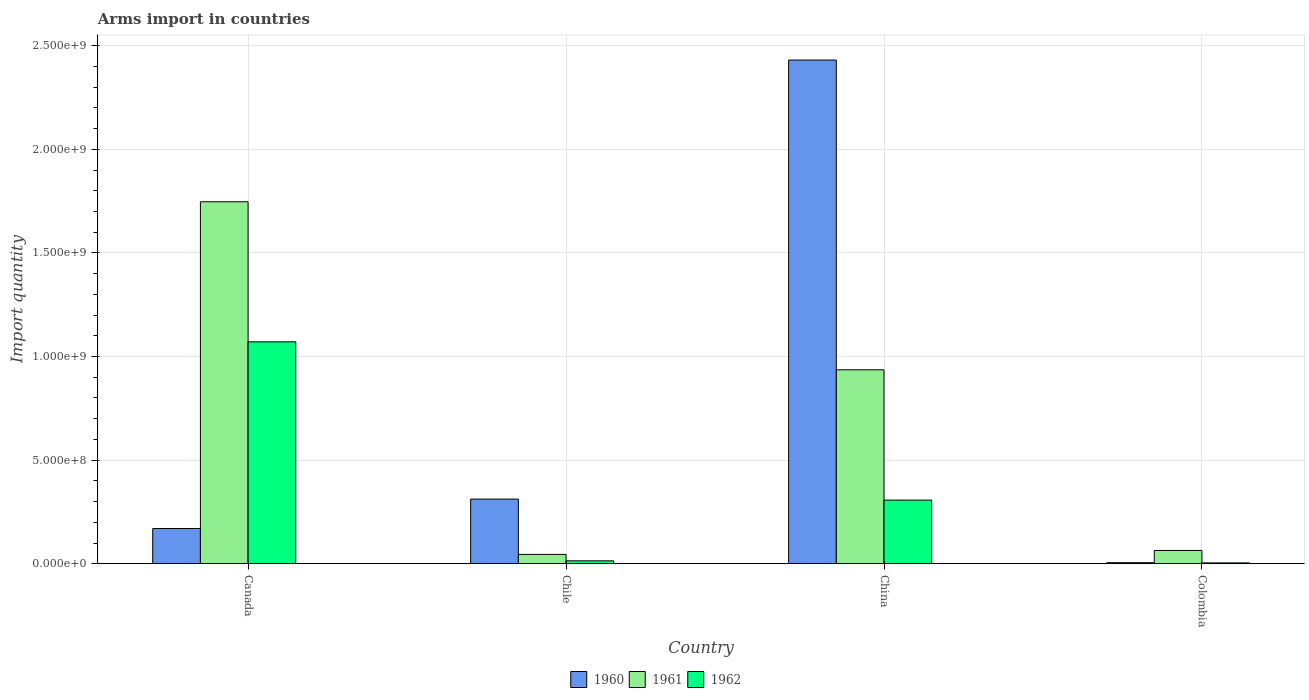Are the number of bars on each tick of the X-axis equal?
Your answer should be compact. Yes. How many bars are there on the 4th tick from the left?
Your response must be concise. 3. How many bars are there on the 4th tick from the right?
Provide a succinct answer. 3. What is the label of the 4th group of bars from the left?
Offer a terse response. Colombia. In how many cases, is the number of bars for a given country not equal to the number of legend labels?
Make the answer very short. 0. What is the total arms import in 1960 in China?
Offer a terse response. 2.43e+09. Across all countries, what is the maximum total arms import in 1961?
Provide a succinct answer. 1.75e+09. Across all countries, what is the minimum total arms import in 1962?
Your answer should be very brief. 4.00e+06. What is the total total arms import in 1961 in the graph?
Offer a very short reply. 2.79e+09. What is the difference between the total arms import in 1962 in China and that in Colombia?
Provide a succinct answer. 3.03e+08. What is the difference between the total arms import in 1961 in Colombia and the total arms import in 1960 in Canada?
Provide a short and direct response. -1.06e+08. What is the average total arms import in 1961 per country?
Provide a short and direct response. 6.98e+08. What is the difference between the total arms import of/in 1962 and total arms import of/in 1960 in Canada?
Give a very brief answer. 9.01e+08. In how many countries, is the total arms import in 1961 greater than 2300000000?
Give a very brief answer. 0. What is the ratio of the total arms import in 1961 in Canada to that in Chile?
Give a very brief answer. 38.82. Is the total arms import in 1960 in China less than that in Colombia?
Your answer should be very brief. No. What is the difference between the highest and the second highest total arms import in 1962?
Give a very brief answer. 1.06e+09. What is the difference between the highest and the lowest total arms import in 1960?
Provide a succinct answer. 2.43e+09. What does the 1st bar from the left in Chile represents?
Your response must be concise. 1960. Is it the case that in every country, the sum of the total arms import in 1962 and total arms import in 1961 is greater than the total arms import in 1960?
Provide a succinct answer. No. Are all the bars in the graph horizontal?
Give a very brief answer. No. How many countries are there in the graph?
Provide a succinct answer. 4. Are the values on the major ticks of Y-axis written in scientific E-notation?
Your response must be concise. Yes. Does the graph contain grids?
Your answer should be compact. Yes. What is the title of the graph?
Ensure brevity in your answer.  Arms import in countries. What is the label or title of the X-axis?
Provide a short and direct response. Country. What is the label or title of the Y-axis?
Provide a succinct answer. Import quantity. What is the Import quantity of 1960 in Canada?
Offer a terse response. 1.70e+08. What is the Import quantity of 1961 in Canada?
Keep it short and to the point. 1.75e+09. What is the Import quantity in 1962 in Canada?
Make the answer very short. 1.07e+09. What is the Import quantity in 1960 in Chile?
Offer a very short reply. 3.12e+08. What is the Import quantity of 1961 in Chile?
Your answer should be compact. 4.50e+07. What is the Import quantity in 1962 in Chile?
Provide a succinct answer. 1.40e+07. What is the Import quantity in 1960 in China?
Ensure brevity in your answer.  2.43e+09. What is the Import quantity in 1961 in China?
Give a very brief answer. 9.36e+08. What is the Import quantity of 1962 in China?
Provide a succinct answer. 3.07e+08. What is the Import quantity of 1961 in Colombia?
Offer a terse response. 6.40e+07. What is the Import quantity of 1962 in Colombia?
Provide a short and direct response. 4.00e+06. Across all countries, what is the maximum Import quantity in 1960?
Your answer should be compact. 2.43e+09. Across all countries, what is the maximum Import quantity in 1961?
Ensure brevity in your answer.  1.75e+09. Across all countries, what is the maximum Import quantity of 1962?
Keep it short and to the point. 1.07e+09. Across all countries, what is the minimum Import quantity of 1960?
Offer a very short reply. 5.00e+06. Across all countries, what is the minimum Import quantity of 1961?
Your answer should be compact. 4.50e+07. Across all countries, what is the minimum Import quantity in 1962?
Make the answer very short. 4.00e+06. What is the total Import quantity of 1960 in the graph?
Make the answer very short. 2.92e+09. What is the total Import quantity of 1961 in the graph?
Provide a short and direct response. 2.79e+09. What is the total Import quantity in 1962 in the graph?
Offer a terse response. 1.40e+09. What is the difference between the Import quantity in 1960 in Canada and that in Chile?
Provide a succinct answer. -1.42e+08. What is the difference between the Import quantity in 1961 in Canada and that in Chile?
Provide a short and direct response. 1.70e+09. What is the difference between the Import quantity in 1962 in Canada and that in Chile?
Ensure brevity in your answer.  1.06e+09. What is the difference between the Import quantity of 1960 in Canada and that in China?
Make the answer very short. -2.26e+09. What is the difference between the Import quantity in 1961 in Canada and that in China?
Ensure brevity in your answer.  8.11e+08. What is the difference between the Import quantity of 1962 in Canada and that in China?
Keep it short and to the point. 7.64e+08. What is the difference between the Import quantity of 1960 in Canada and that in Colombia?
Offer a very short reply. 1.65e+08. What is the difference between the Import quantity of 1961 in Canada and that in Colombia?
Provide a short and direct response. 1.68e+09. What is the difference between the Import quantity of 1962 in Canada and that in Colombia?
Provide a succinct answer. 1.07e+09. What is the difference between the Import quantity of 1960 in Chile and that in China?
Offer a terse response. -2.12e+09. What is the difference between the Import quantity of 1961 in Chile and that in China?
Provide a succinct answer. -8.91e+08. What is the difference between the Import quantity in 1962 in Chile and that in China?
Make the answer very short. -2.93e+08. What is the difference between the Import quantity in 1960 in Chile and that in Colombia?
Your response must be concise. 3.07e+08. What is the difference between the Import quantity in 1961 in Chile and that in Colombia?
Your answer should be compact. -1.90e+07. What is the difference between the Import quantity in 1962 in Chile and that in Colombia?
Make the answer very short. 1.00e+07. What is the difference between the Import quantity of 1960 in China and that in Colombia?
Ensure brevity in your answer.  2.43e+09. What is the difference between the Import quantity in 1961 in China and that in Colombia?
Your response must be concise. 8.72e+08. What is the difference between the Import quantity of 1962 in China and that in Colombia?
Your answer should be very brief. 3.03e+08. What is the difference between the Import quantity in 1960 in Canada and the Import quantity in 1961 in Chile?
Your answer should be very brief. 1.25e+08. What is the difference between the Import quantity in 1960 in Canada and the Import quantity in 1962 in Chile?
Your answer should be very brief. 1.56e+08. What is the difference between the Import quantity in 1961 in Canada and the Import quantity in 1962 in Chile?
Provide a short and direct response. 1.73e+09. What is the difference between the Import quantity of 1960 in Canada and the Import quantity of 1961 in China?
Your answer should be very brief. -7.66e+08. What is the difference between the Import quantity in 1960 in Canada and the Import quantity in 1962 in China?
Your response must be concise. -1.37e+08. What is the difference between the Import quantity in 1961 in Canada and the Import quantity in 1962 in China?
Provide a short and direct response. 1.44e+09. What is the difference between the Import quantity in 1960 in Canada and the Import quantity in 1961 in Colombia?
Provide a succinct answer. 1.06e+08. What is the difference between the Import quantity of 1960 in Canada and the Import quantity of 1962 in Colombia?
Give a very brief answer. 1.66e+08. What is the difference between the Import quantity of 1961 in Canada and the Import quantity of 1962 in Colombia?
Keep it short and to the point. 1.74e+09. What is the difference between the Import quantity in 1960 in Chile and the Import quantity in 1961 in China?
Keep it short and to the point. -6.24e+08. What is the difference between the Import quantity in 1961 in Chile and the Import quantity in 1962 in China?
Ensure brevity in your answer.  -2.62e+08. What is the difference between the Import quantity of 1960 in Chile and the Import quantity of 1961 in Colombia?
Provide a short and direct response. 2.48e+08. What is the difference between the Import quantity in 1960 in Chile and the Import quantity in 1962 in Colombia?
Provide a short and direct response. 3.08e+08. What is the difference between the Import quantity of 1961 in Chile and the Import quantity of 1962 in Colombia?
Keep it short and to the point. 4.10e+07. What is the difference between the Import quantity in 1960 in China and the Import quantity in 1961 in Colombia?
Ensure brevity in your answer.  2.37e+09. What is the difference between the Import quantity of 1960 in China and the Import quantity of 1962 in Colombia?
Your answer should be very brief. 2.43e+09. What is the difference between the Import quantity in 1961 in China and the Import quantity in 1962 in Colombia?
Make the answer very short. 9.32e+08. What is the average Import quantity in 1960 per country?
Provide a short and direct response. 7.30e+08. What is the average Import quantity of 1961 per country?
Provide a short and direct response. 6.98e+08. What is the average Import quantity in 1962 per country?
Ensure brevity in your answer.  3.49e+08. What is the difference between the Import quantity in 1960 and Import quantity in 1961 in Canada?
Offer a very short reply. -1.58e+09. What is the difference between the Import quantity in 1960 and Import quantity in 1962 in Canada?
Provide a succinct answer. -9.01e+08. What is the difference between the Import quantity in 1961 and Import quantity in 1962 in Canada?
Offer a very short reply. 6.76e+08. What is the difference between the Import quantity in 1960 and Import quantity in 1961 in Chile?
Your response must be concise. 2.67e+08. What is the difference between the Import quantity in 1960 and Import quantity in 1962 in Chile?
Give a very brief answer. 2.98e+08. What is the difference between the Import quantity of 1961 and Import quantity of 1962 in Chile?
Give a very brief answer. 3.10e+07. What is the difference between the Import quantity of 1960 and Import quantity of 1961 in China?
Make the answer very short. 1.50e+09. What is the difference between the Import quantity of 1960 and Import quantity of 1962 in China?
Give a very brief answer. 2.12e+09. What is the difference between the Import quantity of 1961 and Import quantity of 1962 in China?
Provide a succinct answer. 6.29e+08. What is the difference between the Import quantity in 1960 and Import quantity in 1961 in Colombia?
Give a very brief answer. -5.90e+07. What is the difference between the Import quantity in 1960 and Import quantity in 1962 in Colombia?
Provide a succinct answer. 1.00e+06. What is the difference between the Import quantity of 1961 and Import quantity of 1962 in Colombia?
Provide a short and direct response. 6.00e+07. What is the ratio of the Import quantity of 1960 in Canada to that in Chile?
Provide a short and direct response. 0.54. What is the ratio of the Import quantity of 1961 in Canada to that in Chile?
Keep it short and to the point. 38.82. What is the ratio of the Import quantity of 1962 in Canada to that in Chile?
Ensure brevity in your answer.  76.5. What is the ratio of the Import quantity of 1960 in Canada to that in China?
Offer a terse response. 0.07. What is the ratio of the Import quantity in 1961 in Canada to that in China?
Provide a succinct answer. 1.87. What is the ratio of the Import quantity of 1962 in Canada to that in China?
Offer a very short reply. 3.49. What is the ratio of the Import quantity in 1961 in Canada to that in Colombia?
Offer a very short reply. 27.3. What is the ratio of the Import quantity in 1962 in Canada to that in Colombia?
Provide a succinct answer. 267.75. What is the ratio of the Import quantity of 1960 in Chile to that in China?
Provide a succinct answer. 0.13. What is the ratio of the Import quantity in 1961 in Chile to that in China?
Keep it short and to the point. 0.05. What is the ratio of the Import quantity of 1962 in Chile to that in China?
Offer a very short reply. 0.05. What is the ratio of the Import quantity of 1960 in Chile to that in Colombia?
Your response must be concise. 62.4. What is the ratio of the Import quantity of 1961 in Chile to that in Colombia?
Provide a short and direct response. 0.7. What is the ratio of the Import quantity in 1960 in China to that in Colombia?
Make the answer very short. 486.2. What is the ratio of the Import quantity of 1961 in China to that in Colombia?
Your answer should be very brief. 14.62. What is the ratio of the Import quantity of 1962 in China to that in Colombia?
Offer a terse response. 76.75. What is the difference between the highest and the second highest Import quantity in 1960?
Offer a very short reply. 2.12e+09. What is the difference between the highest and the second highest Import quantity in 1961?
Offer a very short reply. 8.11e+08. What is the difference between the highest and the second highest Import quantity of 1962?
Provide a succinct answer. 7.64e+08. What is the difference between the highest and the lowest Import quantity of 1960?
Give a very brief answer. 2.43e+09. What is the difference between the highest and the lowest Import quantity in 1961?
Give a very brief answer. 1.70e+09. What is the difference between the highest and the lowest Import quantity in 1962?
Give a very brief answer. 1.07e+09. 